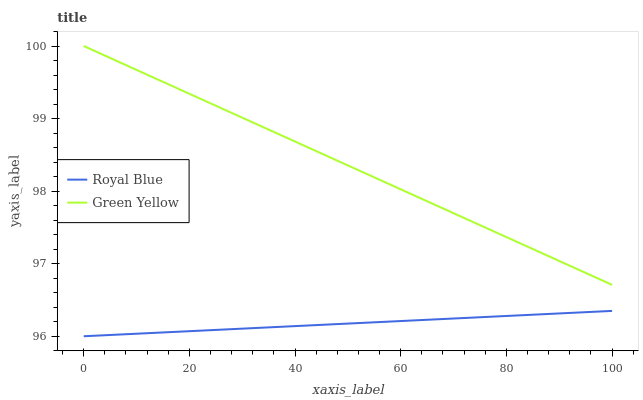Does Green Yellow have the minimum area under the curve?
Answer yes or no. No. Is Green Yellow the smoothest?
Answer yes or no. No. Does Green Yellow have the lowest value?
Answer yes or no. No. Is Royal Blue less than Green Yellow?
Answer yes or no. Yes. Is Green Yellow greater than Royal Blue?
Answer yes or no. Yes. Does Royal Blue intersect Green Yellow?
Answer yes or no. No. 